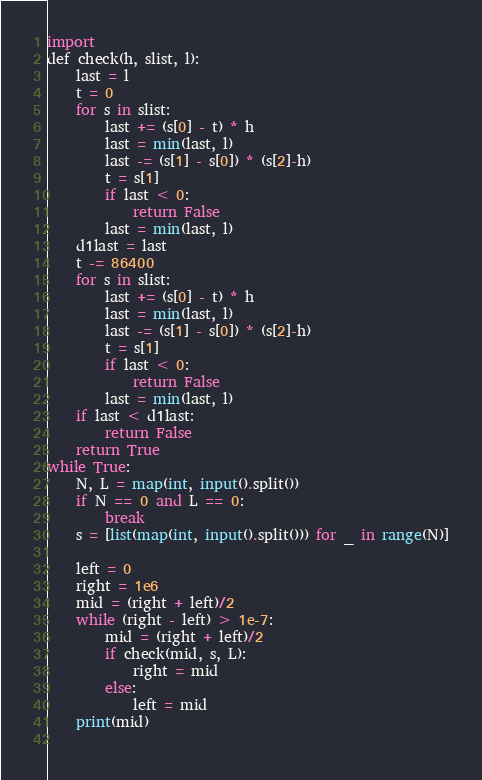Convert code to text. <code><loc_0><loc_0><loc_500><loc_500><_Python_>import 
def check(h, slist, l):
    last = l
    t = 0
    for s in slist:
        last += (s[0] - t) * h
        last = min(last, l)
        last -= (s[1] - s[0]) * (s[2]-h)
        t = s[1]  
        if last < 0:
            return False
        last = min(last, l)
    d1last = last
    t -= 86400
    for s in slist:
        last += (s[0] - t) * h
        last = min(last, l)
        last -= (s[1] - s[0]) * (s[2]-h)
        t = s[1]  
        if last < 0:
            return False
        last = min(last, l)
    if last < d1last:
        return False
    return True
while True:
    N, L = map(int, input().split())
    if N == 0 and L == 0:
        break
    s = [list(map(int, input().split())) for _ in range(N)]

    left = 0
    right = 1e6
    mid = (right + left)/2
    while (right - left) > 1e-7:
        mid = (right + left)/2
        if check(mid, s, L):
            right = mid
        else:
            left = mid
    print(mid)
        </code> 